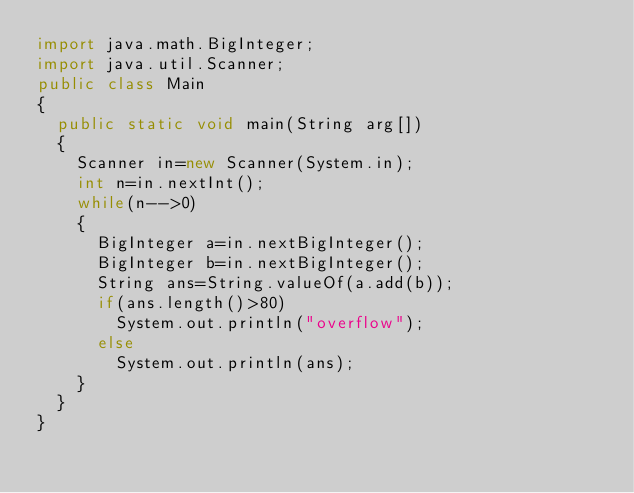<code> <loc_0><loc_0><loc_500><loc_500><_Java_>import java.math.BigInteger;
import java.util.Scanner;
public class Main
{
	public static void main(String arg[])
	{
		Scanner in=new Scanner(System.in);
		int n=in.nextInt();
		while(n-->0)
		{
			BigInteger a=in.nextBigInteger();
			BigInteger b=in.nextBigInteger();
			String ans=String.valueOf(a.add(b));
			if(ans.length()>80)
				System.out.println("overflow");
			else
				System.out.println(ans);
		}
	}
}</code> 